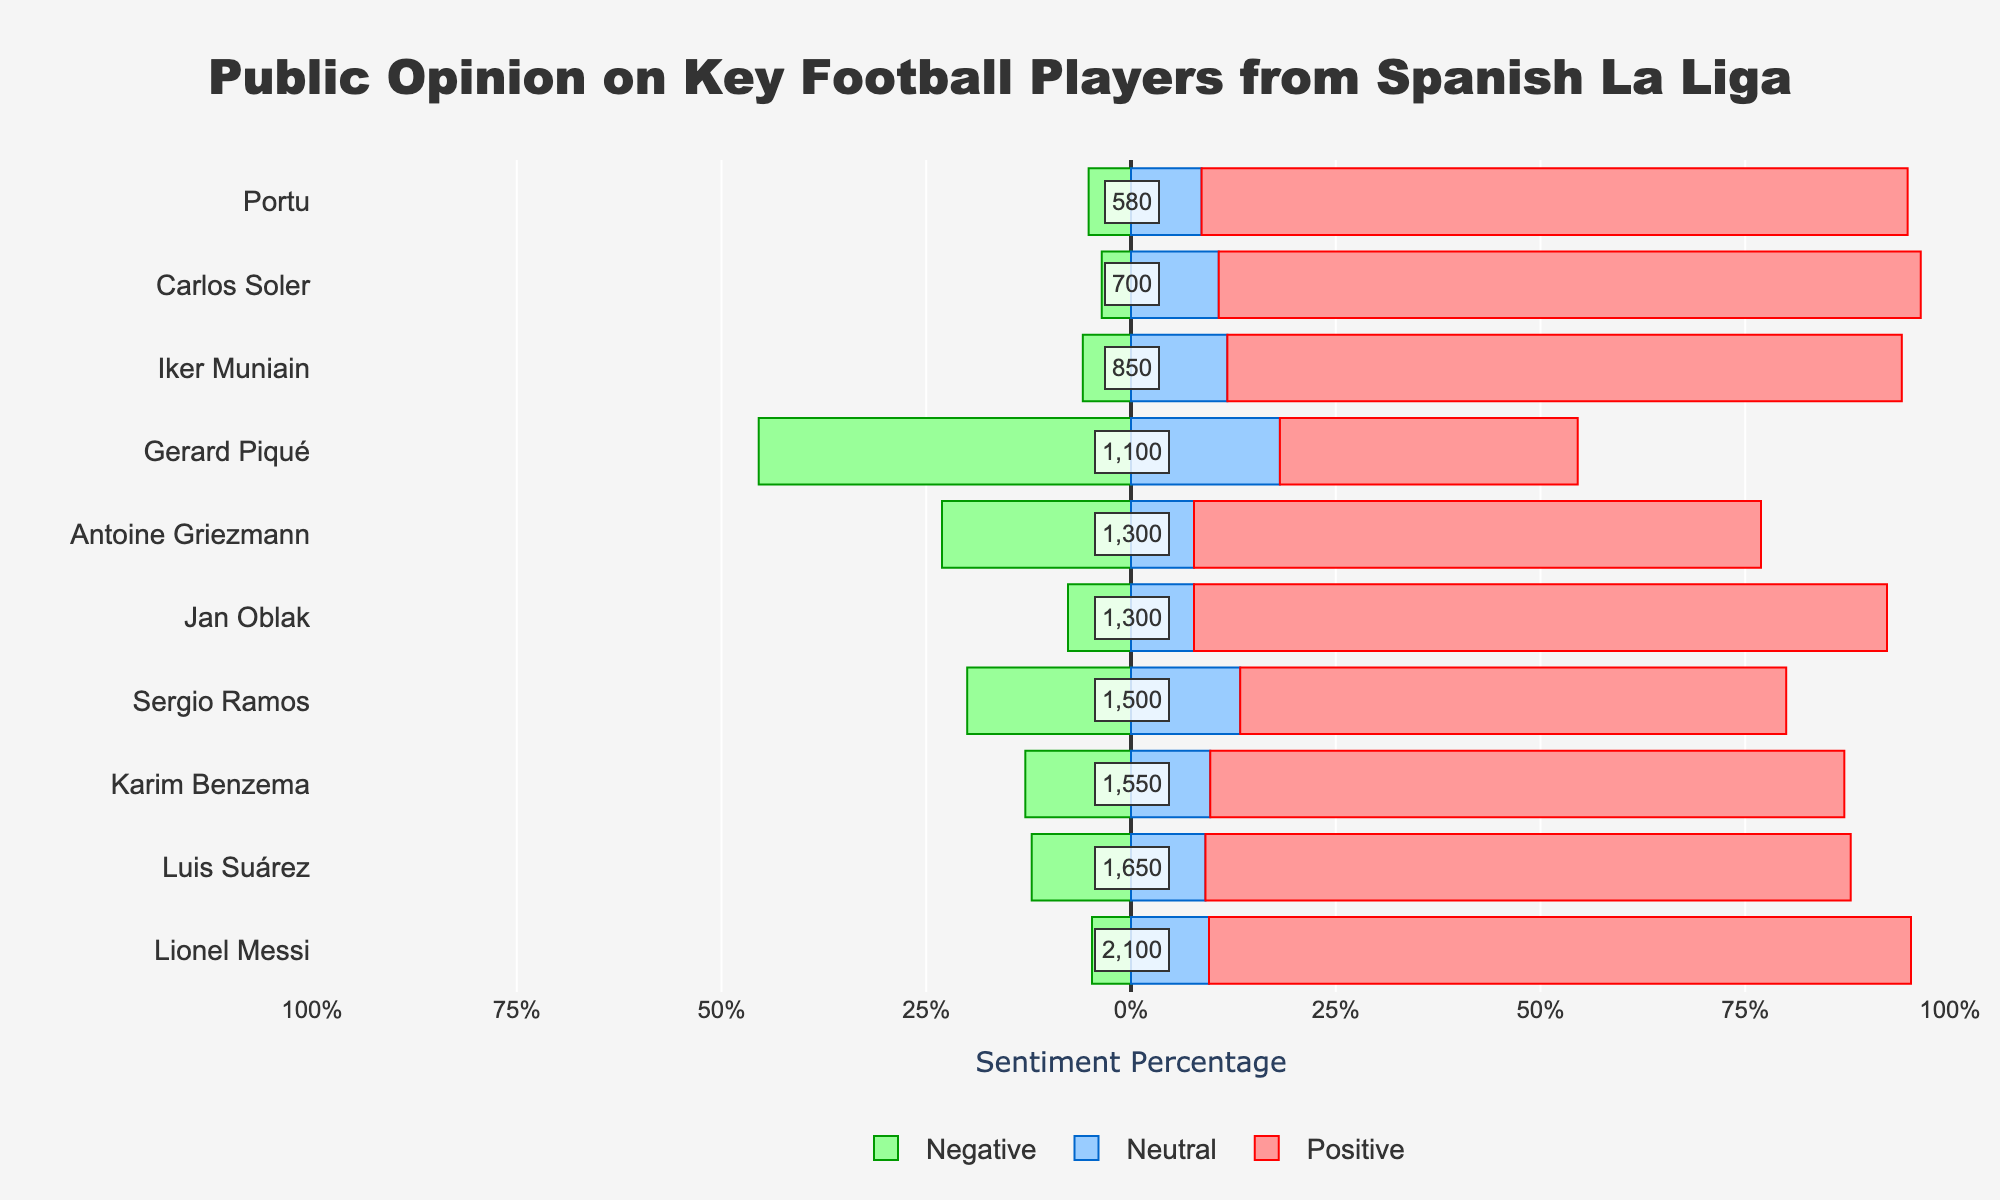Which player has the highest percentage of positive sentiment? By looking at the length of the red bars representing positive sentiment, Lionel Messi has the longest red bar indicating the highest positive sentiment percentage.
Answer: Lionel Messi Which player has the largest amount of negative sentiment in absolute numbers? By checking the descending order of negative bars (green bars to the left), Gerard Piqué has the highest negative sentiment bar.
Answer: Gerard Piqué Who has a higher percentage of neutral sentiment, Antoine Griezmann or Karim Benzema? Compare the lengths of the blue bars (neutral sentiment); Antoine Griezmann's bar is shorter than Karim Benzema's, indicating a lower percentage.
Answer: Karim Benzema What is the total number of sentiments for Sergio Ramos? The total number is annotated next to Sergio Ramos' bar; it is 1500.
Answer: 1500 What's the difference in the percentage of negative sentiment between Luis Suárez and Jan Oblak? Luis Suárez's negative sentiment percentage is around 12.5% and Jan Oblak's is approximately 5.9%. The difference is found by subtracting Jan Oblak's percentage from Luis Suárez's.
Answer: 6.6% Which player has the closest percentage of positive and negative sentiment? By comparing the red and green bars for each player, Gerard Piqué's positive and negative sentiment percentages appear closer to each other than others.
Answer: Gerard Piqué Which two players have the highest percentage of neutral sentiment? The players with the longest blue bars (neutral sentiment) are identified by visual inspection; they are Lionel Messi and Sergio Ramos.
Answer: Lionel Messi, Sergio Ramos How does the negative sentiment percentage for Portu compare to that of Iker Muniain? Compare the lengths of the green bars for negative sentiment; Portu's negative sentiment percentage is smaller than Iker Muniain's.
Answer: Less than What's the sum of the total sentiments for Lionel Messi and Karim Benzema? By adding the total annotations for both players, Lionel Messi (2100) and Karim Benzema (1550), you get 2100 + 1550 = 3650.
Answer: 3650 Which player has the smallest total number of sentiments? The player with the least total sentiment annotation, Portu, has the smallest total number of sentiments (580).
Answer: Portu 